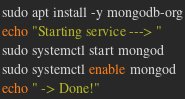<code> <loc_0><loc_0><loc_500><loc_500><_Bash_>sudo apt install -y mongodb-org
echo "Starting service ---> "
sudo systemctl start mongod
sudo systemctl enable mongod
echo " -> Done!"
</code> 